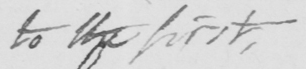Can you read and transcribe this handwriting? to the first 